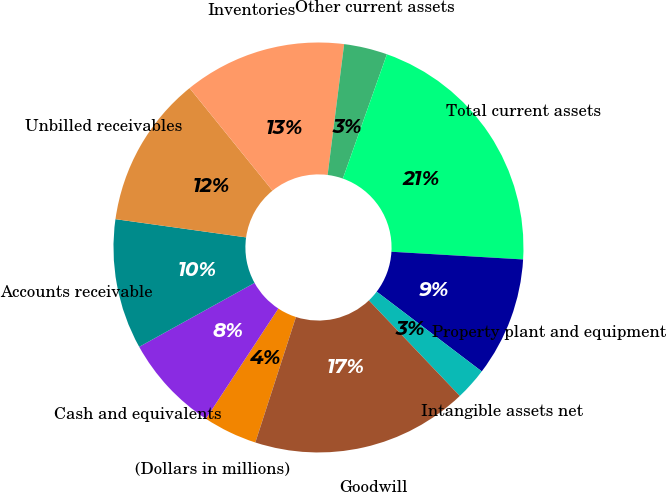Convert chart. <chart><loc_0><loc_0><loc_500><loc_500><pie_chart><fcel>(Dollars in millions)<fcel>Cash and equivalents<fcel>Accounts receivable<fcel>Unbilled receivables<fcel>Inventories<fcel>Other current assets<fcel>Total current assets<fcel>Property plant and equipment<fcel>Intangible assets net<fcel>Goodwill<nl><fcel>4.27%<fcel>7.69%<fcel>10.26%<fcel>11.97%<fcel>12.82%<fcel>3.42%<fcel>20.51%<fcel>9.4%<fcel>2.56%<fcel>17.09%<nl></chart> 